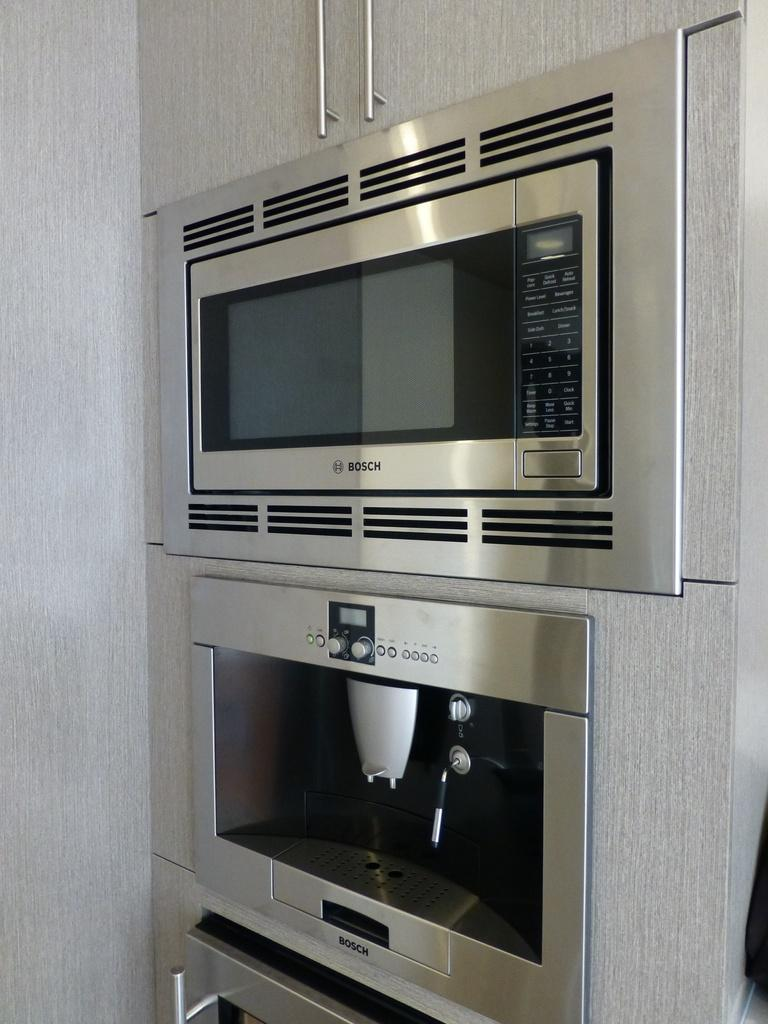<image>
Relay a brief, clear account of the picture shown. A Bosch brand microwave mounted to a wall with another device below 